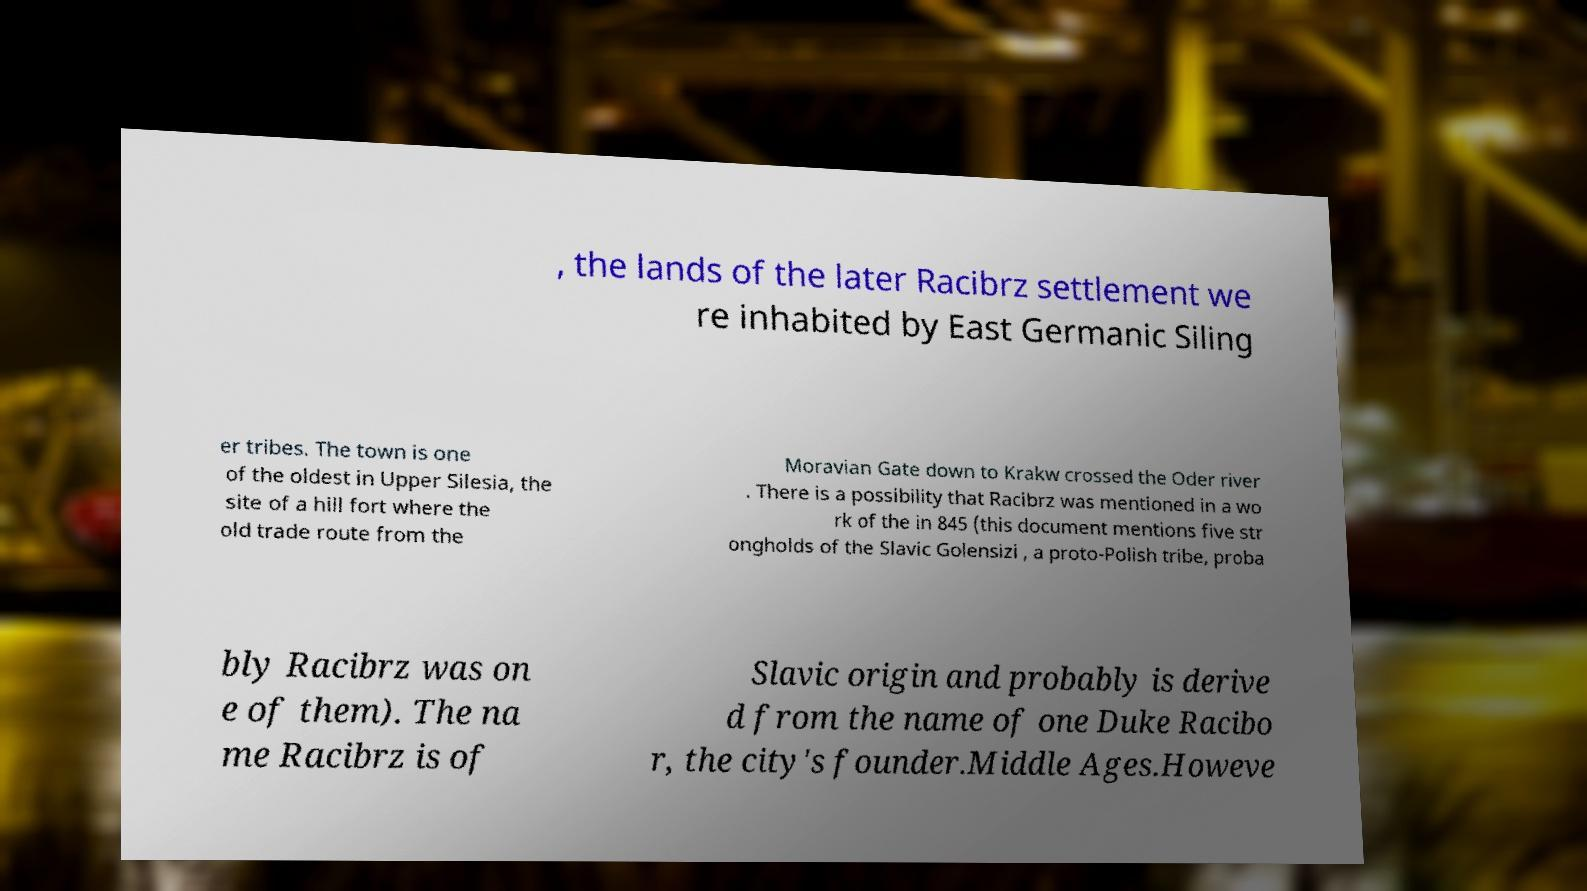Please identify and transcribe the text found in this image. , the lands of the later Racibrz settlement we re inhabited by East Germanic Siling er tribes. The town is one of the oldest in Upper Silesia, the site of a hill fort where the old trade route from the Moravian Gate down to Krakw crossed the Oder river . There is a possibility that Racibrz was mentioned in a wo rk of the in 845 (this document mentions five str ongholds of the Slavic Golensizi , a proto-Polish tribe, proba bly Racibrz was on e of them). The na me Racibrz is of Slavic origin and probably is derive d from the name of one Duke Racibo r, the city's founder.Middle Ages.Howeve 